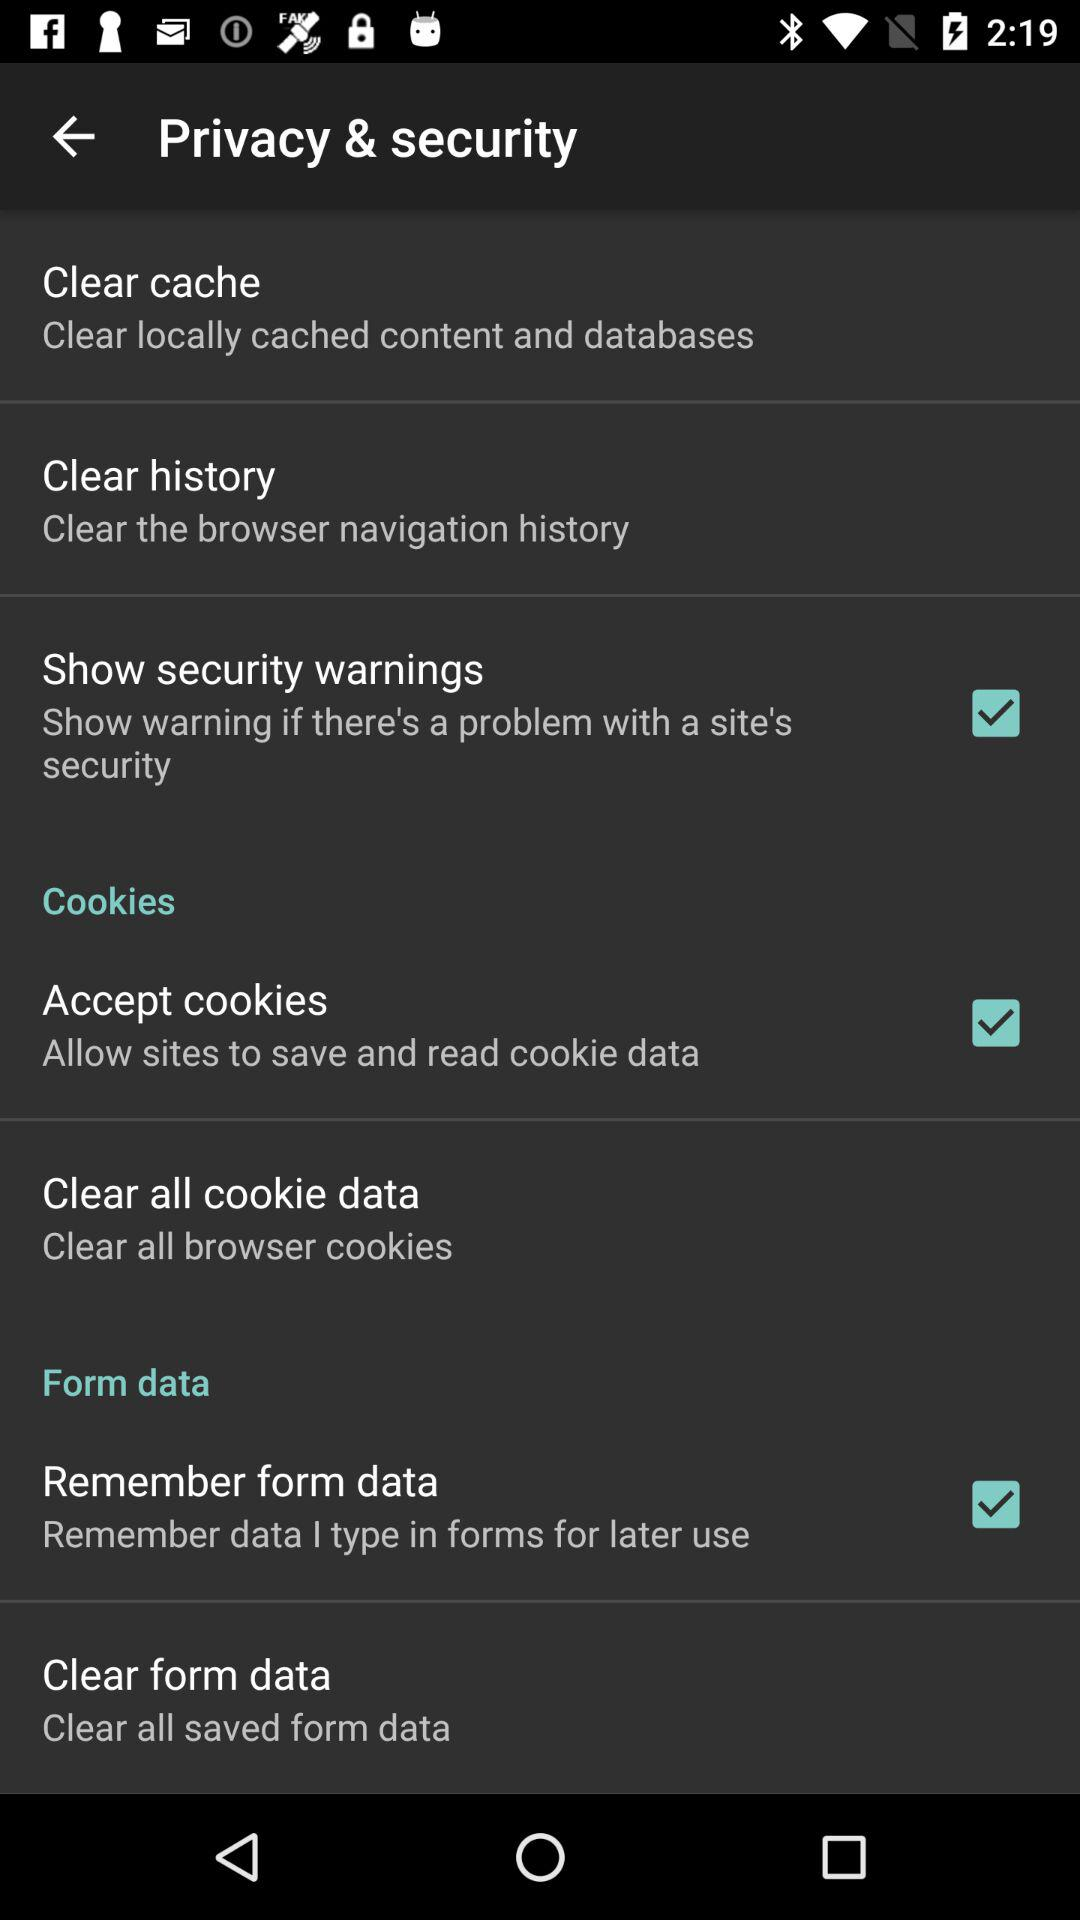How does enabling 'Accept cookies' affect my online privacy? Enabling 'Accept cookies' allows websites to save and read cookie data on your device. This can make your browsing more convenient by remembering login details and setting preferences. However, it also means that websites can track your browsing activities across different sites, which might pose privacy concerns. It's important to balance convenience with your privacy expectations. 